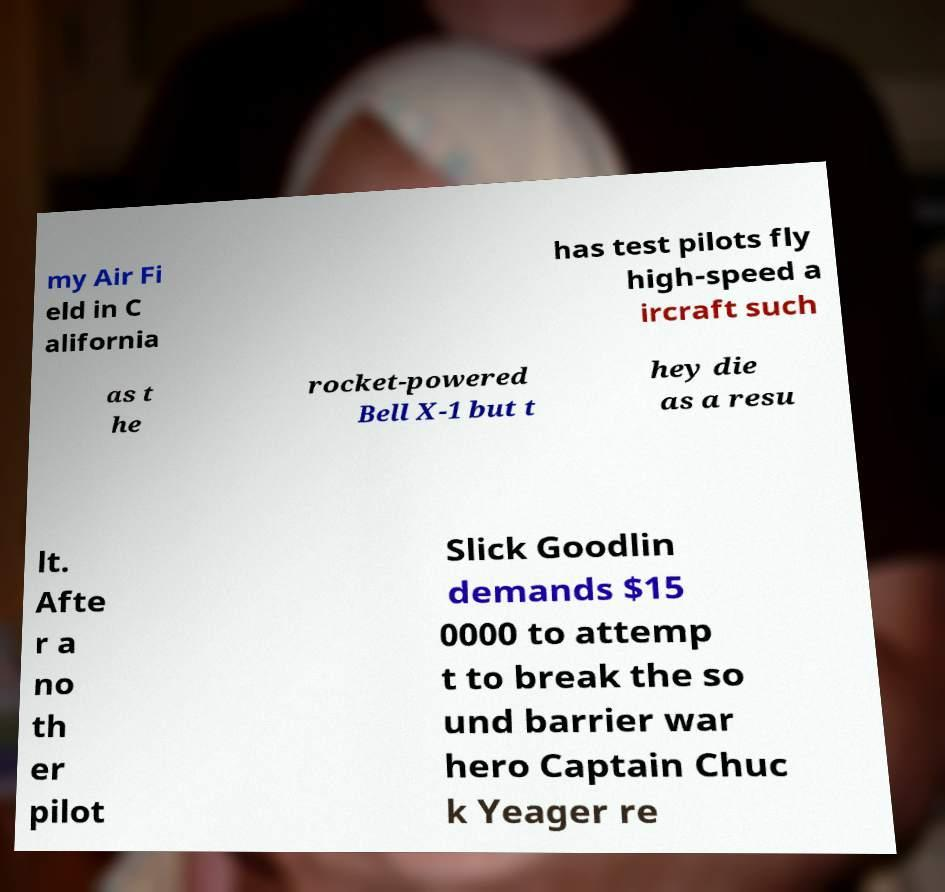Can you accurately transcribe the text from the provided image for me? my Air Fi eld in C alifornia has test pilots fly high-speed a ircraft such as t he rocket-powered Bell X-1 but t hey die as a resu lt. Afte r a no th er pilot Slick Goodlin demands $15 0000 to attemp t to break the so und barrier war hero Captain Chuc k Yeager re 